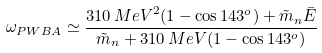<formula> <loc_0><loc_0><loc_500><loc_500>\omega _ { P W B A } \simeq \frac { { 3 1 0 \, M e V } ^ { 2 } ( 1 - \cos 1 4 3 ^ { o } ) + \tilde { m } _ { n } \bar { E } } { \tilde { m } _ { n } + 3 1 0 \, M e V ( 1 - \cos 1 4 3 ^ { o } ) }</formula> 